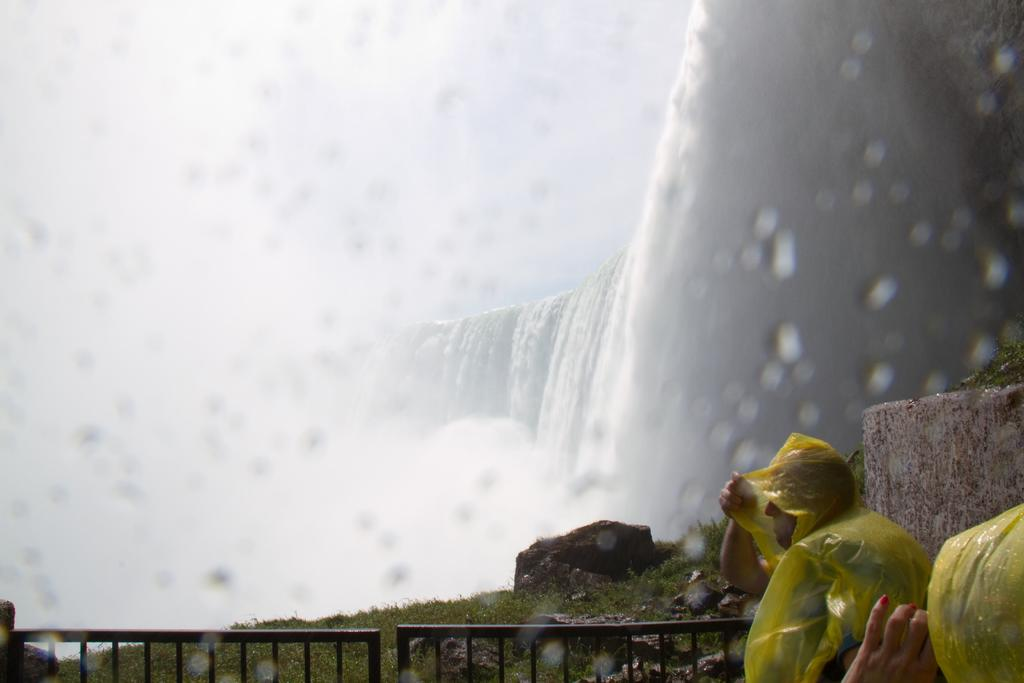What natural feature is present in the image? There is a waterfall in the image. What man-made structure can be seen in the image? There is a fence in the image. Are there any people visible in the image? Yes, people are standing near the fence. What type of bee can be seen buzzing around the waterfall in the image? There are no bees present in the image; it features a waterfall and a fence with people standing nearby. Where is the alley located in the image? There is no alley present in the image; it features a waterfall and a fence with people standing nearby. 